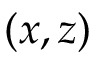<formula> <loc_0><loc_0><loc_500><loc_500>( x , z )</formula> 